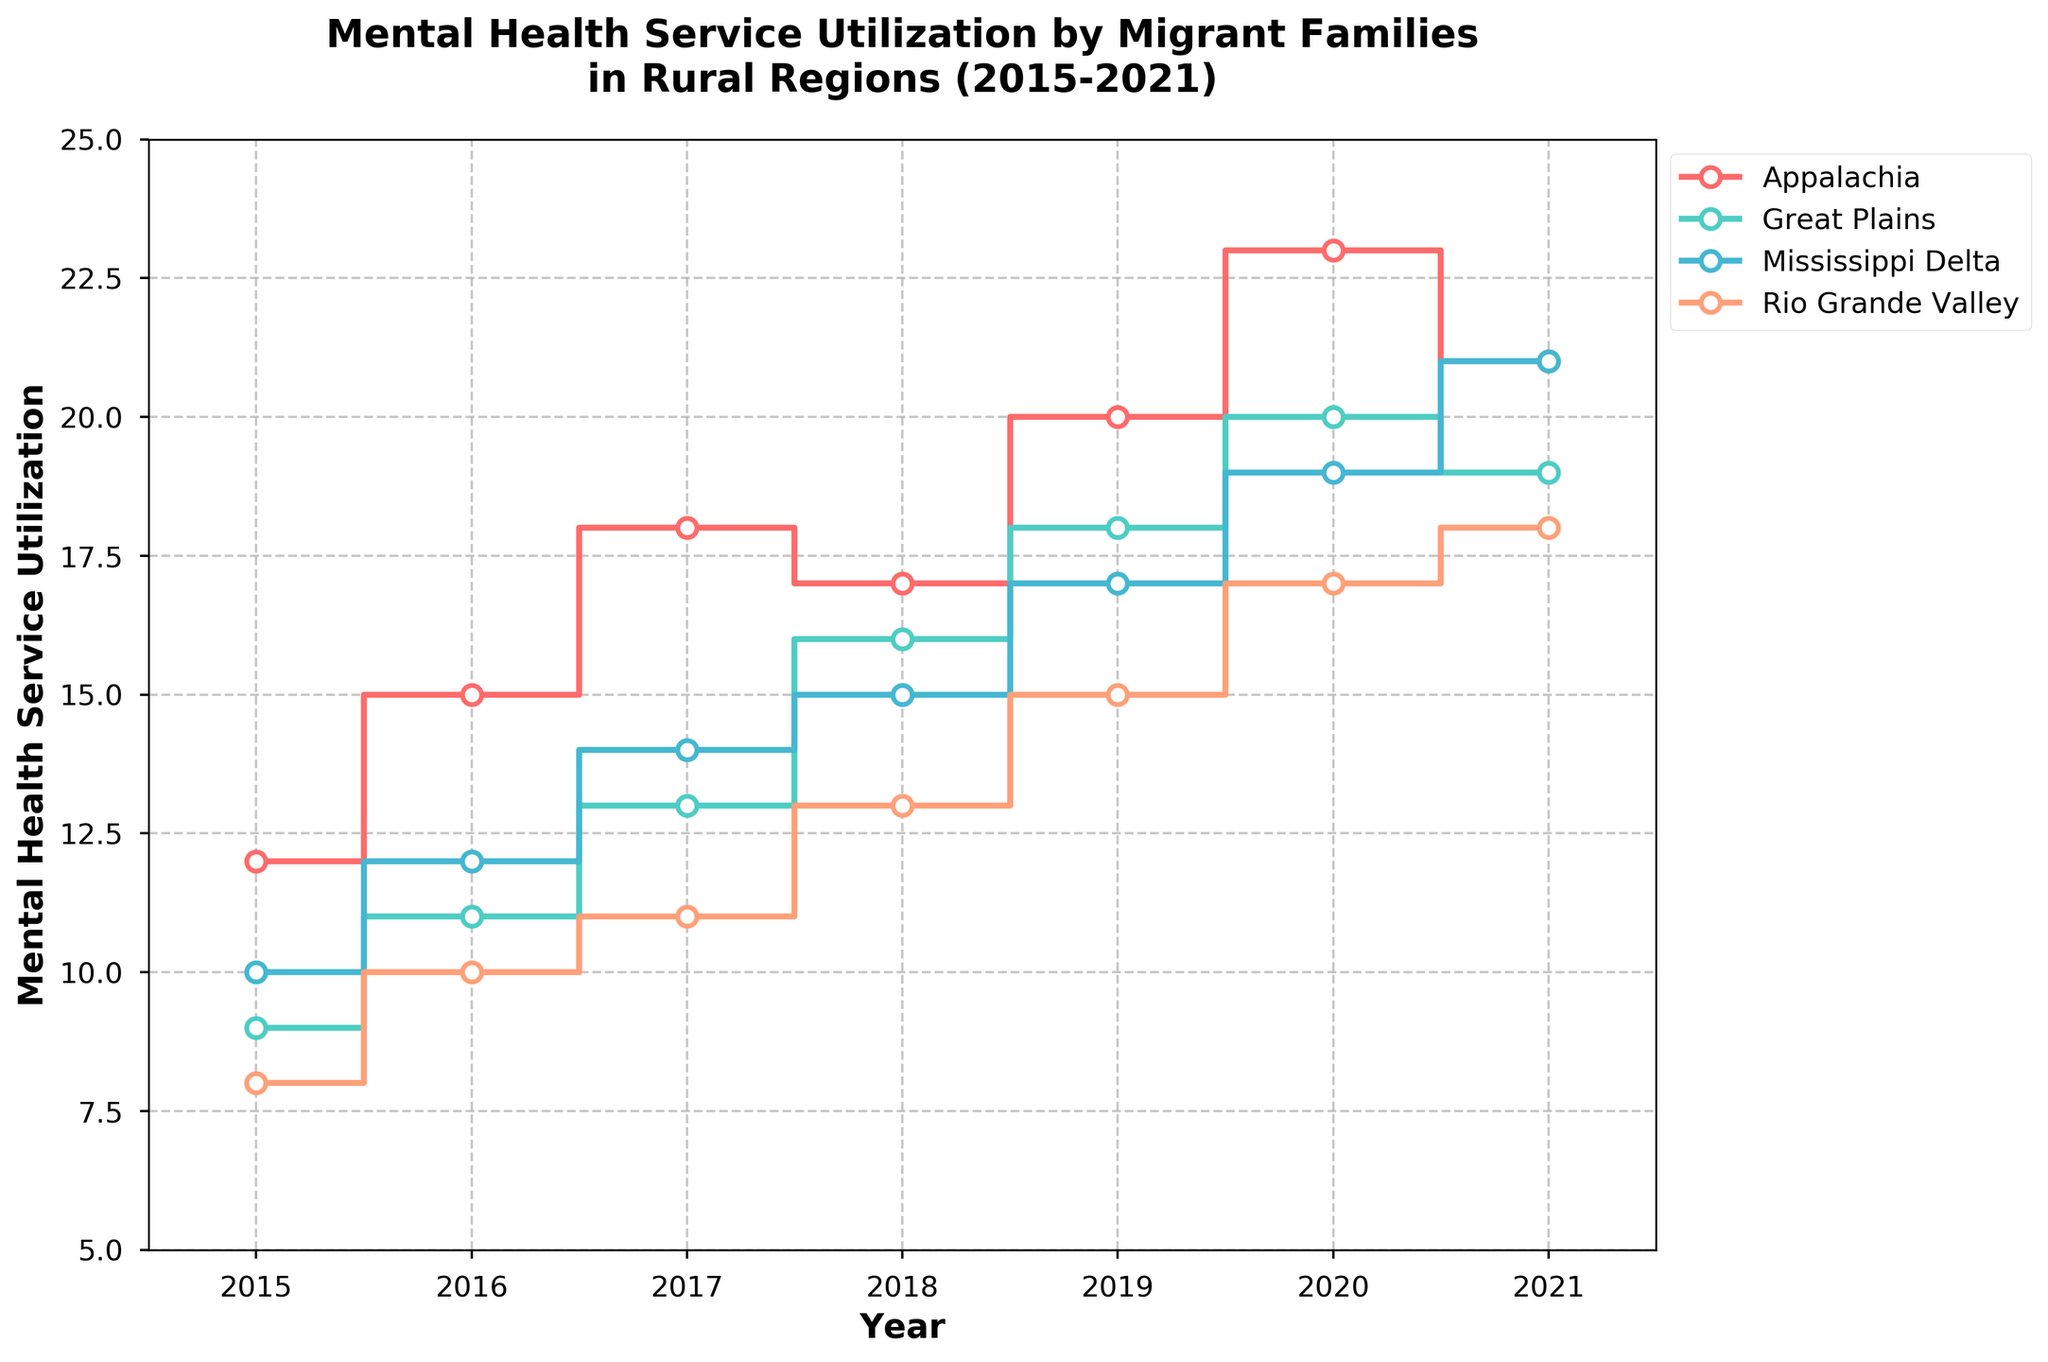What is the title of the figure? The title is a text displayed prominently at the top of the figure. It provides a summary of what the figure is about. In the given figure, the title is "Mental Health Service Utilization by Migrant Families in Rural Regions (2015-2021)".
Answer: Mental Health Service Utilization by Migrant Families in Rural Regions (2015-2021) What is the mental health service utilization value for Appalachian families in 2020? Find the year 2020 on the x-axis, then trace vertically up to the Appalachian line represented in the plot. The point corresponds to the mental health service utilization value for that year. The value is 23.
Answer: 23 Which region had the lowest mental health service utilization in 2015 and what was the value? Find the year 2015 on the x-axis and compare the y-values of the points corresponding to each region. The Rio Grande Valley line is the lowest with a value of 8.
Answer: Rio Grande Valley, 8 How did the mental health service utilization trend for the Mississippi Delta region change from 2015 to 2021? Identify the line representing the Mississippi Delta. Starting from the year 2015 and ending at 2021, observe the direction and height of the points to note the trend. The utilization increased from 10 in 2015 to 21 in 2021, showing a consistent upward trend.
Answer: Consistently increased In which year did the Great Plains region experience the highest mental health service utilization and what was it? Follow the Great Plains line and identify the highest point along the y-axis. The highest utilization occurred in 2020 with a value of 20.
Answer: 2020, 20 Compare the mental health service utilization between the Appalachia and Rio Grande Valley regions in 2019. Which was higher? Locate the year 2019 on the x-axis and identify the points for both Appalachia and Rio Grande Valley. Compare their heights. The Appalachia value is 20, while the Rio Grande Valley value is 15. Therefore, Appalachia's value was higher.
Answer: Appalachia By how much did the mental health service utilization for Great Plains increase from 2015 to 2018? Note the mental health service utilization values for Great Plains for 2015 and 2018. Subtract the 2015 value (9) from the 2018 value (16). The increase is 16 - 9 = 7.
Answer: 7 What is the average mental health service utilization for Appalachia from 2015 to 2021? Add up the annual mental health service utilization values for Appalachia from 2015 to 2021 (12 + 15 + 18 + 17 + 20 + 23 + 21). Divide this sum by the number of years (7). The calculated average is (12 + 15 + 18 + 17 + 20 + 23 + 21) / 7 = 18.
Answer: 18 Which region shows the most consistent increase in mental health service utilization over the years 2015 to 2021? Examine each line to assess the increase in the number of services utilized by year. The Mississippi Delta shows a consistent upward trend without decreases, increasing steadily from 10 in 2015 to 21 in 2021.
Answer: Mississippi Delta 